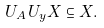Convert formula to latex. <formula><loc_0><loc_0><loc_500><loc_500>U _ { A } U _ { y } X \subseteq X .</formula> 